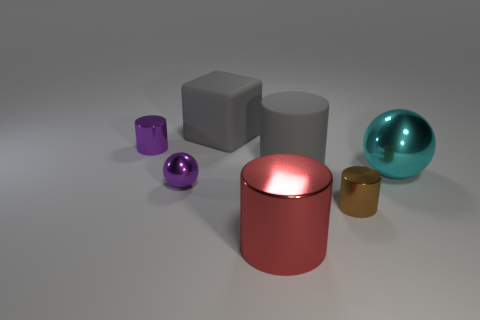What could be the function of these objects if they were real? If these objects were real, their functions might vary. The larger containers, such as the red canister and the gray cylinder, could serve as storage units, bins, or even decorative vases, depending on the material and strength. The spheres may be ornamental or part of a larger mechanical system if they're solid. The cube could be a paperweight or a simple structural element. 